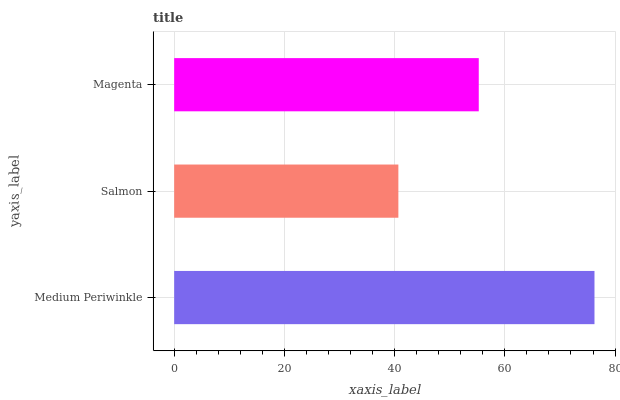Is Salmon the minimum?
Answer yes or no. Yes. Is Medium Periwinkle the maximum?
Answer yes or no. Yes. Is Magenta the minimum?
Answer yes or no. No. Is Magenta the maximum?
Answer yes or no. No. Is Magenta greater than Salmon?
Answer yes or no. Yes. Is Salmon less than Magenta?
Answer yes or no. Yes. Is Salmon greater than Magenta?
Answer yes or no. No. Is Magenta less than Salmon?
Answer yes or no. No. Is Magenta the high median?
Answer yes or no. Yes. Is Magenta the low median?
Answer yes or no. Yes. Is Salmon the high median?
Answer yes or no. No. Is Medium Periwinkle the low median?
Answer yes or no. No. 